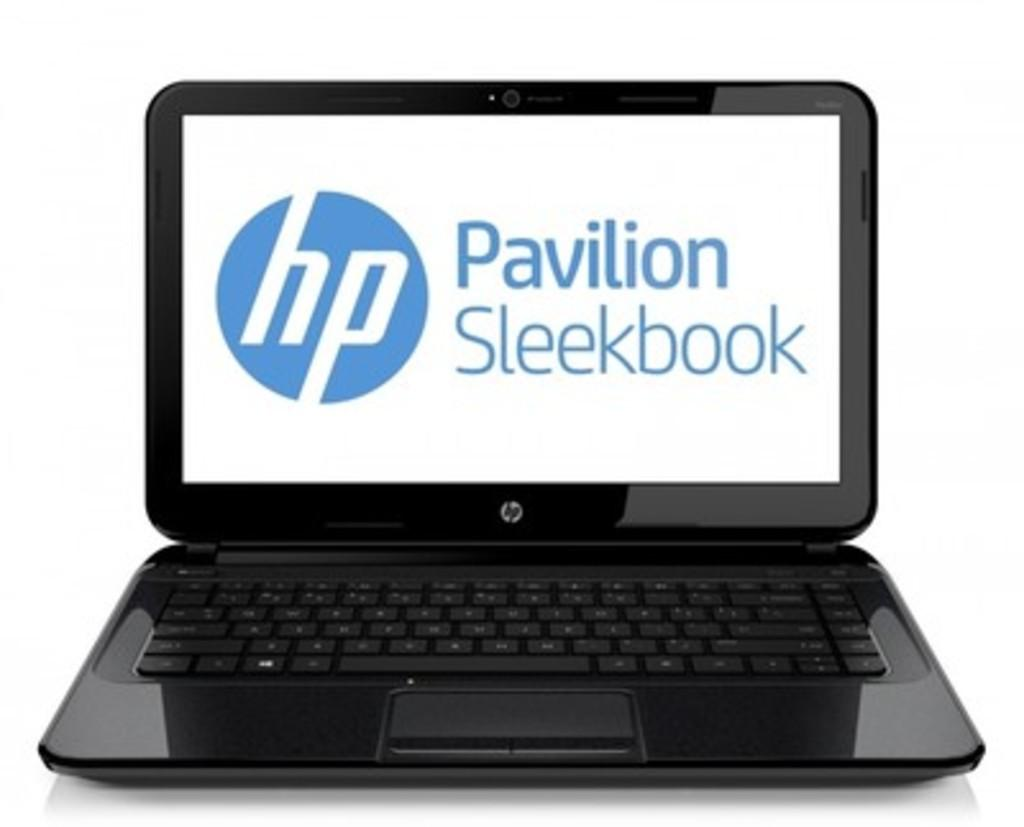<image>
Describe the image concisely. An HP Pavilion Sleekbook is on display on a white background. 